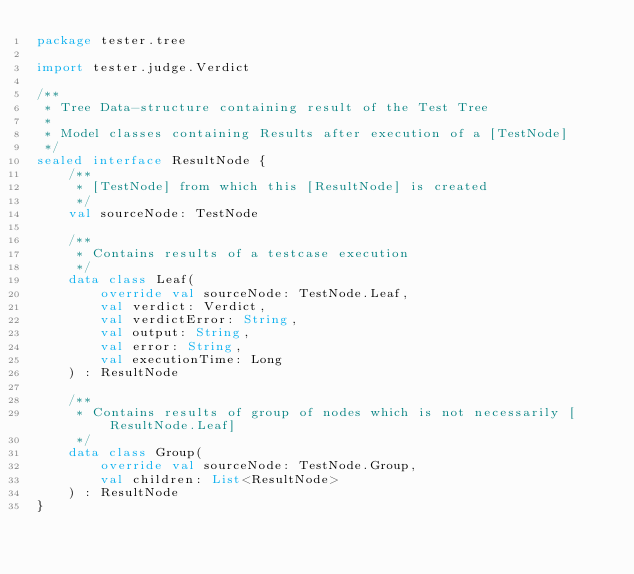<code> <loc_0><loc_0><loc_500><loc_500><_Kotlin_>package tester.tree

import tester.judge.Verdict

/**
 * Tree Data-structure containing result of the Test Tree
 *
 * Model classes containing Results after execution of a [TestNode]
 */
sealed interface ResultNode {
    /**
     * [TestNode] from which this [ResultNode] is created
     */
    val sourceNode: TestNode

    /**
     * Contains results of a testcase execution
     */
    data class Leaf(
        override val sourceNode: TestNode.Leaf,
        val verdict: Verdict,
        val verdictError: String,
        val output: String,
        val error: String,
        val executionTime: Long
    ) : ResultNode

    /**
     * Contains results of group of nodes which is not necessarily [ResultNode.Leaf]
     */
    data class Group(
        override val sourceNode: TestNode.Group,
        val children: List<ResultNode>
    ) : ResultNode
}</code> 